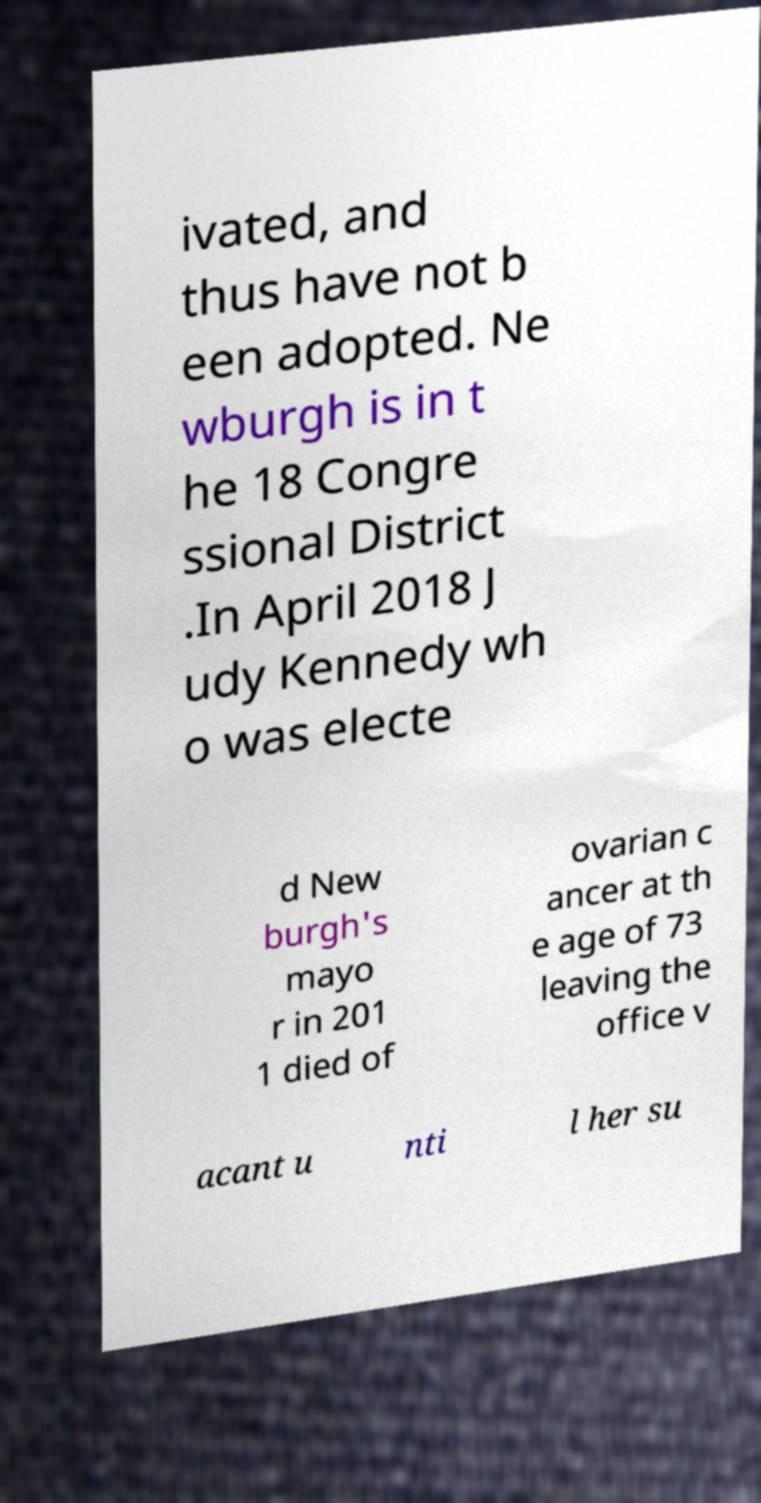Can you accurately transcribe the text from the provided image for me? ivated, and thus have not b een adopted. Ne wburgh is in t he 18 Congre ssional District .In April 2018 J udy Kennedy wh o was electe d New burgh's mayo r in 201 1 died of ovarian c ancer at th e age of 73 leaving the office v acant u nti l her su 